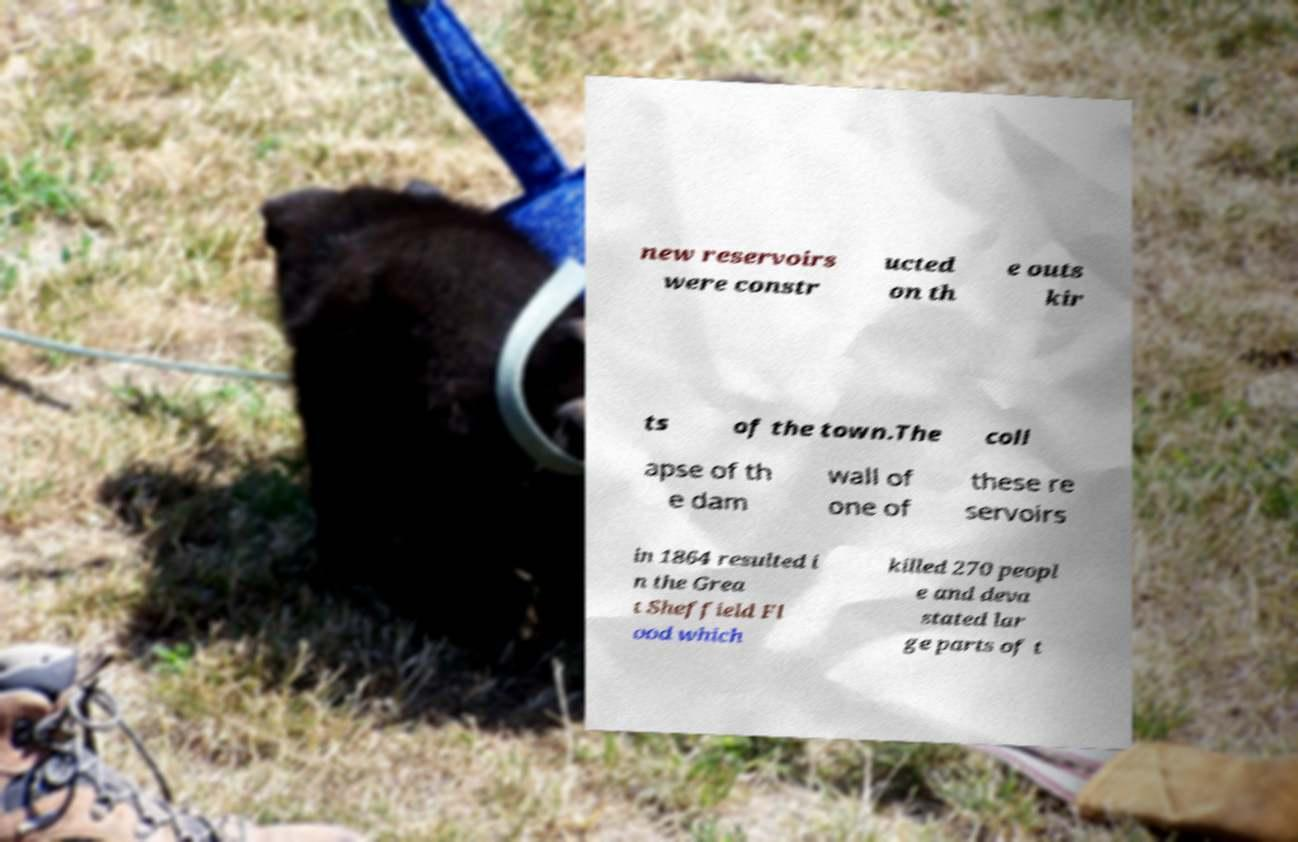Please identify and transcribe the text found in this image. new reservoirs were constr ucted on th e outs kir ts of the town.The coll apse of th e dam wall of one of these re servoirs in 1864 resulted i n the Grea t Sheffield Fl ood which killed 270 peopl e and deva stated lar ge parts of t 